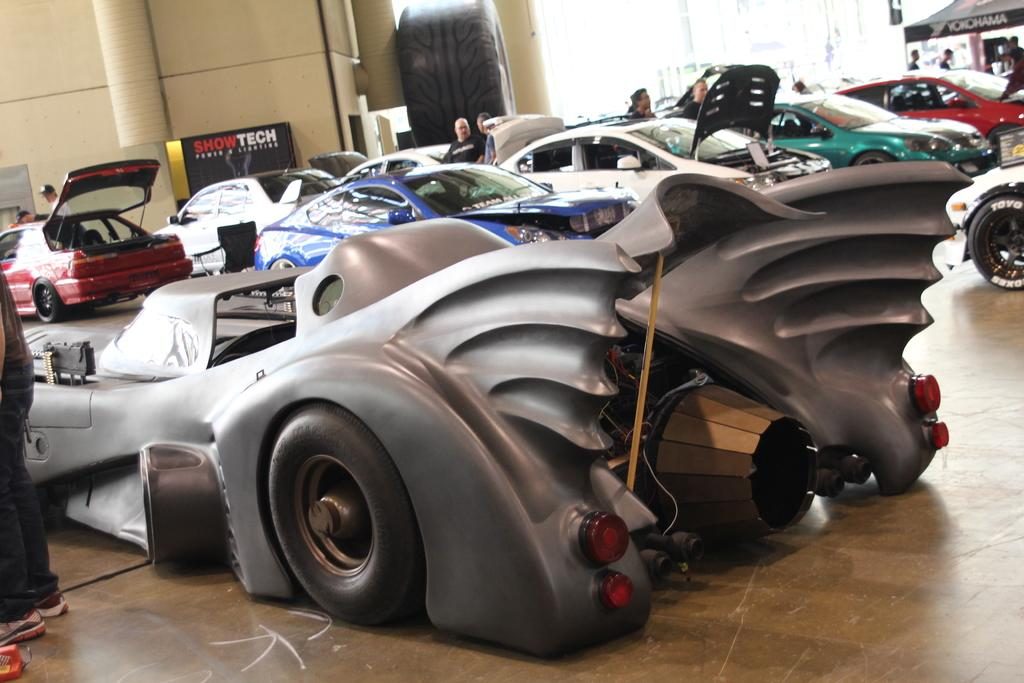What types of objects can be seen in the image? There are vehicles in the image. Are there any living beings present in the image? Yes, there are people in the image. What structure can be seen on the right side of the image? There is a tent on the right side of the image. What can be seen in the background of the image? There is a wall in the background of the image. What type of spot can be seen on the wall in the image? There is no spot visible on the wall in the image. Can you see any sparks coming from the vehicles in the image? There are no sparks visible in the image; the vehicles are not shown in motion or in any situation where sparks would be present. 